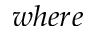Convert formula to latex. <formula><loc_0><loc_0><loc_500><loc_500>w h e r e</formula> 